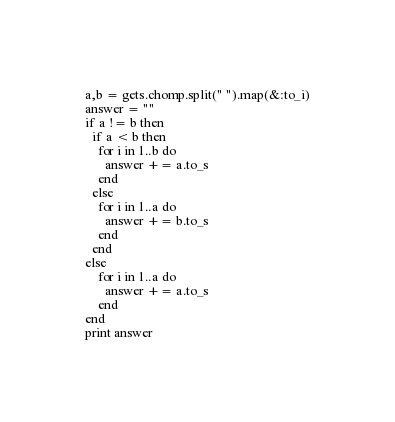Convert code to text. <code><loc_0><loc_0><loc_500><loc_500><_Ruby_>a,b = gets.chomp.split(" ").map(&:to_i)
answer = ""
if a != b then
  if a < b then
    for i in 1..b do
      answer += a.to_s
    end
  else
    for i in 1..a do
      answer += b.to_s
    end
  end
else
    for i in 1..a do
      answer += a.to_s
	end
end
print answer</code> 